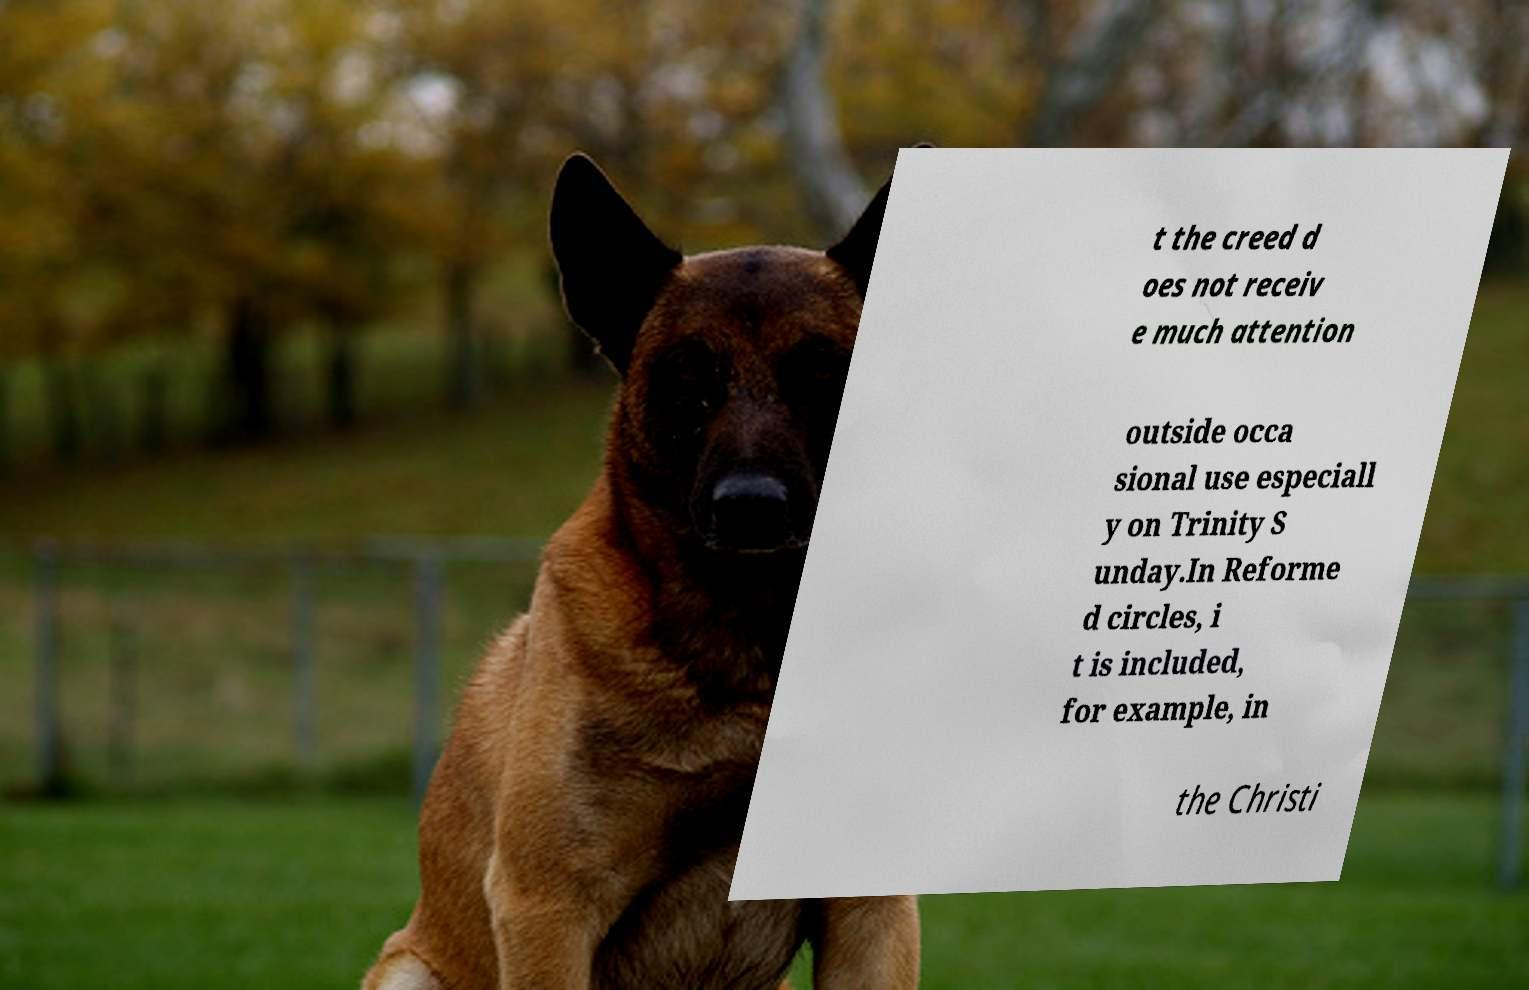Please read and relay the text visible in this image. What does it say? t the creed d oes not receiv e much attention outside occa sional use especiall y on Trinity S unday.In Reforme d circles, i t is included, for example, in the Christi 